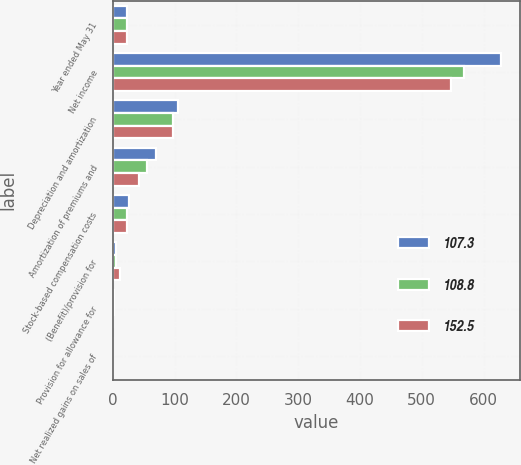Convert chart to OTSL. <chart><loc_0><loc_0><loc_500><loc_500><stacked_bar_chart><ecel><fcel>Year ended May 31<fcel>Net income<fcel>Depreciation and amortization<fcel>Amortization of premiums and<fcel>Stock-based compensation costs<fcel>(Benefit)/provision for<fcel>Provision for allowance for<fcel>Net realized gains on sales of<nl><fcel>107.3<fcel>22.9<fcel>627.5<fcel>105<fcel>70.3<fcel>26.3<fcel>4.9<fcel>2.5<fcel>0.6<nl><fcel>108.8<fcel>22.9<fcel>569<fcel>98.2<fcel>56.2<fcel>22.8<fcel>5.3<fcel>1.7<fcel>0.9<nl><fcel>152.5<fcel>22.9<fcel>548<fcel>97.8<fcel>42.5<fcel>22.9<fcel>11.7<fcel>1.2<fcel>1<nl></chart> 